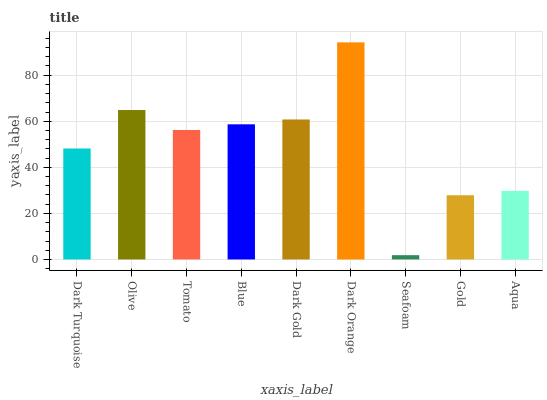Is Seafoam the minimum?
Answer yes or no. Yes. Is Dark Orange the maximum?
Answer yes or no. Yes. Is Olive the minimum?
Answer yes or no. No. Is Olive the maximum?
Answer yes or no. No. Is Olive greater than Dark Turquoise?
Answer yes or no. Yes. Is Dark Turquoise less than Olive?
Answer yes or no. Yes. Is Dark Turquoise greater than Olive?
Answer yes or no. No. Is Olive less than Dark Turquoise?
Answer yes or no. No. Is Tomato the high median?
Answer yes or no. Yes. Is Tomato the low median?
Answer yes or no. Yes. Is Dark Orange the high median?
Answer yes or no. No. Is Seafoam the low median?
Answer yes or no. No. 